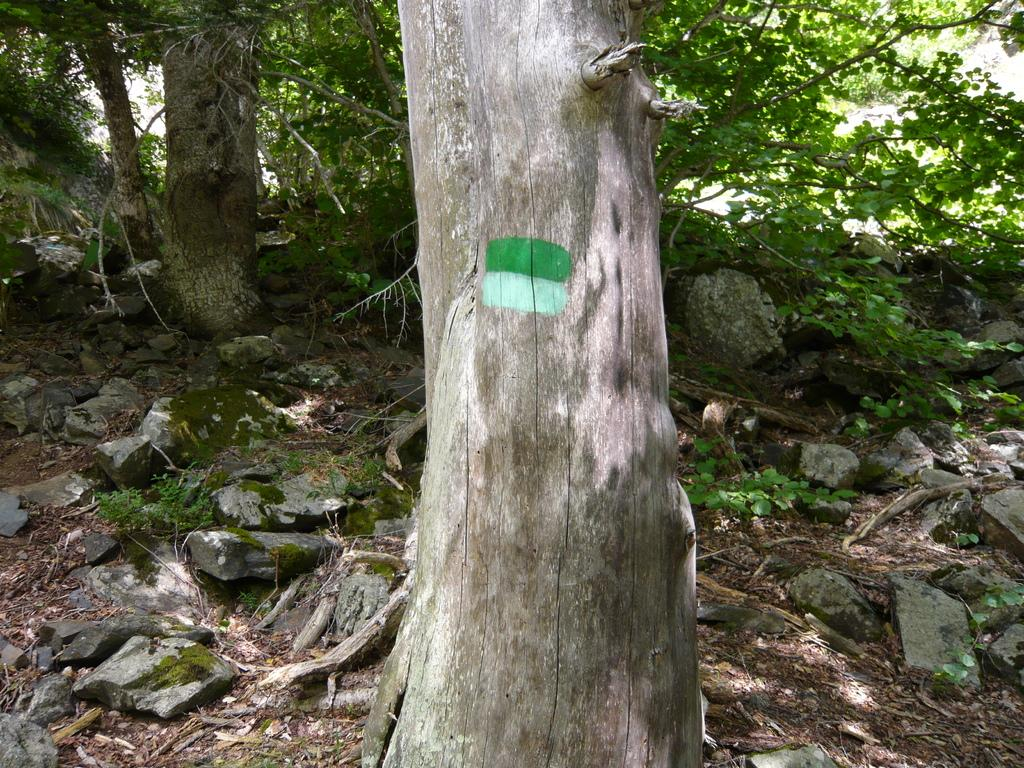What type of vegetation can be seen in the image? There are plants and trees in the image. What other objects or features can be seen in the image? There are rocks in the image. Can you describe the natural environment depicted in the image? The image features plants, trees, and rocks, which suggests a natural outdoor setting. What brand of toothpaste is being advertised in the image? There is no toothpaste or advertisement present in the image. What class of students is shown studying in the image? There are no students or class depicted in the image. 